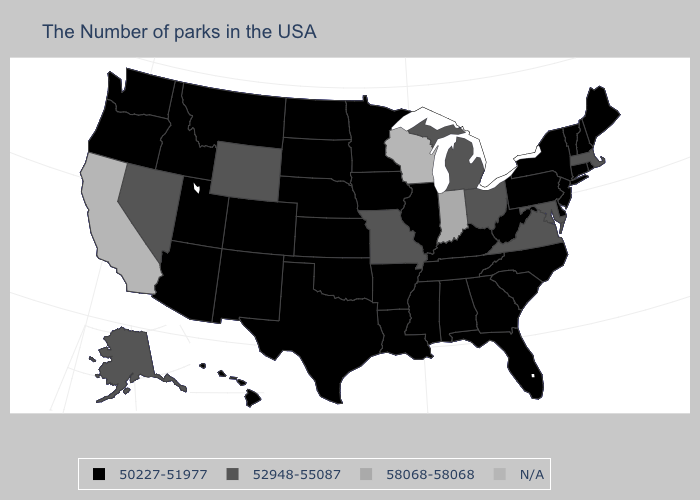Name the states that have a value in the range 52948-55087?
Be succinct. Massachusetts, Maryland, Virginia, Ohio, Michigan, Missouri, Wyoming, Nevada, Alaska. Which states have the highest value in the USA?
Answer briefly. Indiana. Does Tennessee have the lowest value in the South?
Short answer required. Yes. What is the highest value in the USA?
Write a very short answer. 58068-58068. Name the states that have a value in the range N/A?
Quick response, please. Wisconsin, California. What is the value of Kansas?
Answer briefly. 50227-51977. What is the value of New York?
Give a very brief answer. 50227-51977. Does Connecticut have the highest value in the USA?
Write a very short answer. No. What is the value of Alaska?
Quick response, please. 52948-55087. Does New Jersey have the lowest value in the Northeast?
Keep it brief. Yes. Does the first symbol in the legend represent the smallest category?
Be succinct. Yes. What is the value of North Dakota?
Short answer required. 50227-51977. What is the value of Utah?
Concise answer only. 50227-51977. Which states hav the highest value in the West?
Concise answer only. Wyoming, Nevada, Alaska. 